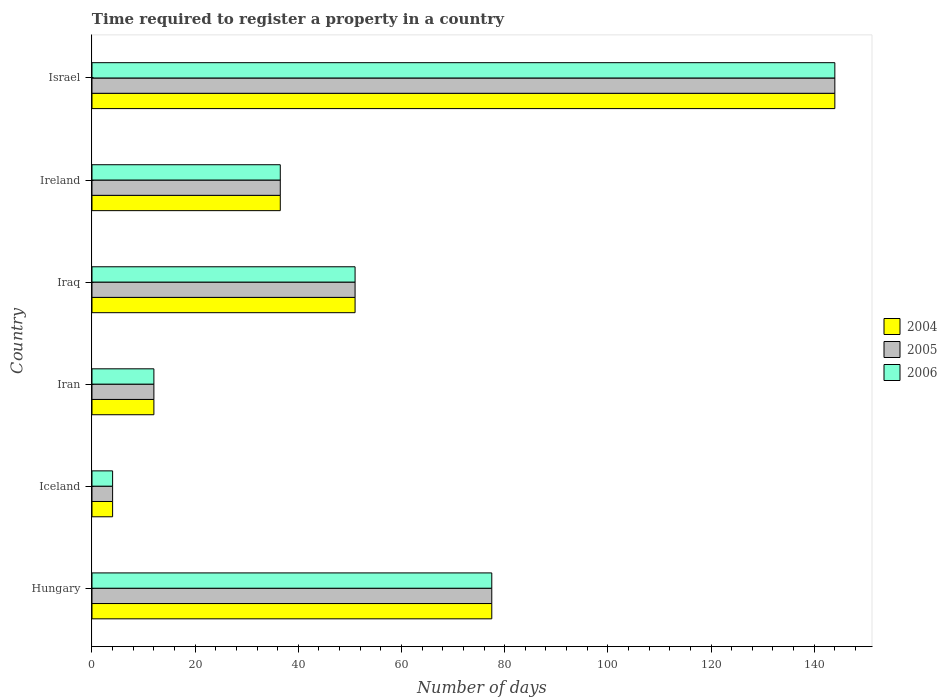How many groups of bars are there?
Your answer should be compact. 6. Are the number of bars on each tick of the Y-axis equal?
Provide a short and direct response. Yes. How many bars are there on the 1st tick from the top?
Keep it short and to the point. 3. What is the number of days required to register a property in 2004 in Iran?
Provide a short and direct response. 12. Across all countries, what is the maximum number of days required to register a property in 2006?
Your response must be concise. 144. Across all countries, what is the minimum number of days required to register a property in 2005?
Provide a succinct answer. 4. What is the total number of days required to register a property in 2006 in the graph?
Keep it short and to the point. 325. What is the difference between the number of days required to register a property in 2005 in Iraq and the number of days required to register a property in 2006 in Iran?
Give a very brief answer. 39. What is the average number of days required to register a property in 2005 per country?
Offer a very short reply. 54.17. In how many countries, is the number of days required to register a property in 2006 greater than 100 days?
Your answer should be compact. 1. What is the ratio of the number of days required to register a property in 2004 in Hungary to that in Iraq?
Ensure brevity in your answer.  1.52. Is the number of days required to register a property in 2005 in Iceland less than that in Iraq?
Offer a terse response. Yes. What is the difference between the highest and the second highest number of days required to register a property in 2004?
Provide a succinct answer. 66.5. What is the difference between the highest and the lowest number of days required to register a property in 2004?
Ensure brevity in your answer.  140. What does the 3rd bar from the bottom in Iraq represents?
Your answer should be compact. 2006. Is it the case that in every country, the sum of the number of days required to register a property in 2006 and number of days required to register a property in 2005 is greater than the number of days required to register a property in 2004?
Offer a terse response. Yes. How many bars are there?
Your answer should be very brief. 18. How many countries are there in the graph?
Offer a terse response. 6. Are the values on the major ticks of X-axis written in scientific E-notation?
Give a very brief answer. No. How many legend labels are there?
Your answer should be compact. 3. What is the title of the graph?
Keep it short and to the point. Time required to register a property in a country. Does "2012" appear as one of the legend labels in the graph?
Provide a short and direct response. No. What is the label or title of the X-axis?
Give a very brief answer. Number of days. What is the label or title of the Y-axis?
Your answer should be compact. Country. What is the Number of days in 2004 in Hungary?
Give a very brief answer. 77.5. What is the Number of days of 2005 in Hungary?
Your answer should be compact. 77.5. What is the Number of days in 2006 in Hungary?
Your answer should be very brief. 77.5. What is the Number of days in 2005 in Iceland?
Keep it short and to the point. 4. What is the Number of days in 2006 in Iceland?
Provide a short and direct response. 4. What is the Number of days in 2005 in Iran?
Give a very brief answer. 12. What is the Number of days in 2006 in Iran?
Offer a very short reply. 12. What is the Number of days in 2005 in Iraq?
Your answer should be compact. 51. What is the Number of days in 2006 in Iraq?
Provide a succinct answer. 51. What is the Number of days in 2004 in Ireland?
Your answer should be very brief. 36.5. What is the Number of days of 2005 in Ireland?
Your answer should be very brief. 36.5. What is the Number of days in 2006 in Ireland?
Offer a terse response. 36.5. What is the Number of days in 2004 in Israel?
Make the answer very short. 144. What is the Number of days in 2005 in Israel?
Keep it short and to the point. 144. What is the Number of days in 2006 in Israel?
Keep it short and to the point. 144. Across all countries, what is the maximum Number of days in 2004?
Your answer should be compact. 144. Across all countries, what is the maximum Number of days in 2005?
Offer a very short reply. 144. Across all countries, what is the maximum Number of days of 2006?
Provide a succinct answer. 144. Across all countries, what is the minimum Number of days in 2004?
Provide a short and direct response. 4. What is the total Number of days in 2004 in the graph?
Keep it short and to the point. 325. What is the total Number of days of 2005 in the graph?
Keep it short and to the point. 325. What is the total Number of days of 2006 in the graph?
Your answer should be very brief. 325. What is the difference between the Number of days in 2004 in Hungary and that in Iceland?
Ensure brevity in your answer.  73.5. What is the difference between the Number of days in 2005 in Hungary and that in Iceland?
Your answer should be very brief. 73.5. What is the difference between the Number of days of 2006 in Hungary and that in Iceland?
Give a very brief answer. 73.5. What is the difference between the Number of days of 2004 in Hungary and that in Iran?
Keep it short and to the point. 65.5. What is the difference between the Number of days in 2005 in Hungary and that in Iran?
Keep it short and to the point. 65.5. What is the difference between the Number of days of 2006 in Hungary and that in Iran?
Your answer should be compact. 65.5. What is the difference between the Number of days in 2004 in Hungary and that in Iraq?
Offer a terse response. 26.5. What is the difference between the Number of days of 2004 in Hungary and that in Ireland?
Provide a succinct answer. 41. What is the difference between the Number of days of 2005 in Hungary and that in Ireland?
Provide a succinct answer. 41. What is the difference between the Number of days of 2004 in Hungary and that in Israel?
Your answer should be very brief. -66.5. What is the difference between the Number of days in 2005 in Hungary and that in Israel?
Give a very brief answer. -66.5. What is the difference between the Number of days in 2006 in Hungary and that in Israel?
Your answer should be very brief. -66.5. What is the difference between the Number of days of 2004 in Iceland and that in Iran?
Your answer should be very brief. -8. What is the difference between the Number of days of 2005 in Iceland and that in Iran?
Your response must be concise. -8. What is the difference between the Number of days of 2004 in Iceland and that in Iraq?
Provide a short and direct response. -47. What is the difference between the Number of days of 2005 in Iceland and that in Iraq?
Your response must be concise. -47. What is the difference between the Number of days in 2006 in Iceland and that in Iraq?
Your answer should be compact. -47. What is the difference between the Number of days of 2004 in Iceland and that in Ireland?
Give a very brief answer. -32.5. What is the difference between the Number of days in 2005 in Iceland and that in Ireland?
Provide a succinct answer. -32.5. What is the difference between the Number of days of 2006 in Iceland and that in Ireland?
Keep it short and to the point. -32.5. What is the difference between the Number of days in 2004 in Iceland and that in Israel?
Keep it short and to the point. -140. What is the difference between the Number of days of 2005 in Iceland and that in Israel?
Ensure brevity in your answer.  -140. What is the difference between the Number of days in 2006 in Iceland and that in Israel?
Your response must be concise. -140. What is the difference between the Number of days in 2004 in Iran and that in Iraq?
Your answer should be very brief. -39. What is the difference between the Number of days of 2005 in Iran and that in Iraq?
Your answer should be compact. -39. What is the difference between the Number of days of 2006 in Iran and that in Iraq?
Ensure brevity in your answer.  -39. What is the difference between the Number of days of 2004 in Iran and that in Ireland?
Provide a succinct answer. -24.5. What is the difference between the Number of days in 2005 in Iran and that in Ireland?
Your response must be concise. -24.5. What is the difference between the Number of days in 2006 in Iran and that in Ireland?
Your response must be concise. -24.5. What is the difference between the Number of days in 2004 in Iran and that in Israel?
Provide a succinct answer. -132. What is the difference between the Number of days of 2005 in Iran and that in Israel?
Provide a succinct answer. -132. What is the difference between the Number of days in 2006 in Iran and that in Israel?
Provide a succinct answer. -132. What is the difference between the Number of days in 2004 in Iraq and that in Ireland?
Ensure brevity in your answer.  14.5. What is the difference between the Number of days in 2005 in Iraq and that in Ireland?
Keep it short and to the point. 14.5. What is the difference between the Number of days in 2004 in Iraq and that in Israel?
Your response must be concise. -93. What is the difference between the Number of days of 2005 in Iraq and that in Israel?
Provide a short and direct response. -93. What is the difference between the Number of days of 2006 in Iraq and that in Israel?
Keep it short and to the point. -93. What is the difference between the Number of days in 2004 in Ireland and that in Israel?
Your response must be concise. -107.5. What is the difference between the Number of days in 2005 in Ireland and that in Israel?
Keep it short and to the point. -107.5. What is the difference between the Number of days of 2006 in Ireland and that in Israel?
Your answer should be very brief. -107.5. What is the difference between the Number of days of 2004 in Hungary and the Number of days of 2005 in Iceland?
Your answer should be very brief. 73.5. What is the difference between the Number of days of 2004 in Hungary and the Number of days of 2006 in Iceland?
Keep it short and to the point. 73.5. What is the difference between the Number of days of 2005 in Hungary and the Number of days of 2006 in Iceland?
Your answer should be very brief. 73.5. What is the difference between the Number of days of 2004 in Hungary and the Number of days of 2005 in Iran?
Your answer should be compact. 65.5. What is the difference between the Number of days in 2004 in Hungary and the Number of days in 2006 in Iran?
Offer a terse response. 65.5. What is the difference between the Number of days in 2005 in Hungary and the Number of days in 2006 in Iran?
Offer a very short reply. 65.5. What is the difference between the Number of days of 2004 in Hungary and the Number of days of 2005 in Iraq?
Provide a short and direct response. 26.5. What is the difference between the Number of days in 2004 in Hungary and the Number of days in 2006 in Iraq?
Make the answer very short. 26.5. What is the difference between the Number of days of 2005 in Hungary and the Number of days of 2006 in Iraq?
Provide a short and direct response. 26.5. What is the difference between the Number of days in 2004 in Hungary and the Number of days in 2005 in Ireland?
Your response must be concise. 41. What is the difference between the Number of days in 2004 in Hungary and the Number of days in 2005 in Israel?
Your answer should be very brief. -66.5. What is the difference between the Number of days in 2004 in Hungary and the Number of days in 2006 in Israel?
Make the answer very short. -66.5. What is the difference between the Number of days of 2005 in Hungary and the Number of days of 2006 in Israel?
Make the answer very short. -66.5. What is the difference between the Number of days of 2004 in Iceland and the Number of days of 2005 in Iran?
Keep it short and to the point. -8. What is the difference between the Number of days in 2004 in Iceland and the Number of days in 2006 in Iran?
Provide a succinct answer. -8. What is the difference between the Number of days in 2004 in Iceland and the Number of days in 2005 in Iraq?
Your answer should be compact. -47. What is the difference between the Number of days in 2004 in Iceland and the Number of days in 2006 in Iraq?
Give a very brief answer. -47. What is the difference between the Number of days in 2005 in Iceland and the Number of days in 2006 in Iraq?
Give a very brief answer. -47. What is the difference between the Number of days of 2004 in Iceland and the Number of days of 2005 in Ireland?
Your answer should be compact. -32.5. What is the difference between the Number of days of 2004 in Iceland and the Number of days of 2006 in Ireland?
Provide a succinct answer. -32.5. What is the difference between the Number of days of 2005 in Iceland and the Number of days of 2006 in Ireland?
Your answer should be very brief. -32.5. What is the difference between the Number of days in 2004 in Iceland and the Number of days in 2005 in Israel?
Give a very brief answer. -140. What is the difference between the Number of days in 2004 in Iceland and the Number of days in 2006 in Israel?
Your response must be concise. -140. What is the difference between the Number of days of 2005 in Iceland and the Number of days of 2006 in Israel?
Make the answer very short. -140. What is the difference between the Number of days of 2004 in Iran and the Number of days of 2005 in Iraq?
Provide a succinct answer. -39. What is the difference between the Number of days in 2004 in Iran and the Number of days in 2006 in Iraq?
Make the answer very short. -39. What is the difference between the Number of days in 2005 in Iran and the Number of days in 2006 in Iraq?
Your response must be concise. -39. What is the difference between the Number of days in 2004 in Iran and the Number of days in 2005 in Ireland?
Offer a terse response. -24.5. What is the difference between the Number of days of 2004 in Iran and the Number of days of 2006 in Ireland?
Your answer should be very brief. -24.5. What is the difference between the Number of days of 2005 in Iran and the Number of days of 2006 in Ireland?
Offer a very short reply. -24.5. What is the difference between the Number of days of 2004 in Iran and the Number of days of 2005 in Israel?
Your answer should be very brief. -132. What is the difference between the Number of days in 2004 in Iran and the Number of days in 2006 in Israel?
Provide a short and direct response. -132. What is the difference between the Number of days in 2005 in Iran and the Number of days in 2006 in Israel?
Your response must be concise. -132. What is the difference between the Number of days in 2004 in Iraq and the Number of days in 2005 in Israel?
Make the answer very short. -93. What is the difference between the Number of days of 2004 in Iraq and the Number of days of 2006 in Israel?
Ensure brevity in your answer.  -93. What is the difference between the Number of days of 2005 in Iraq and the Number of days of 2006 in Israel?
Keep it short and to the point. -93. What is the difference between the Number of days in 2004 in Ireland and the Number of days in 2005 in Israel?
Your answer should be compact. -107.5. What is the difference between the Number of days of 2004 in Ireland and the Number of days of 2006 in Israel?
Provide a succinct answer. -107.5. What is the difference between the Number of days of 2005 in Ireland and the Number of days of 2006 in Israel?
Give a very brief answer. -107.5. What is the average Number of days in 2004 per country?
Offer a very short reply. 54.17. What is the average Number of days of 2005 per country?
Your answer should be compact. 54.17. What is the average Number of days in 2006 per country?
Your response must be concise. 54.17. What is the difference between the Number of days of 2005 and Number of days of 2006 in Hungary?
Provide a succinct answer. 0. What is the difference between the Number of days in 2004 and Number of days in 2006 in Iceland?
Provide a succinct answer. 0. What is the difference between the Number of days in 2005 and Number of days in 2006 in Iceland?
Your answer should be very brief. 0. What is the difference between the Number of days in 2004 and Number of days in 2005 in Iran?
Offer a terse response. 0. What is the difference between the Number of days of 2004 and Number of days of 2006 in Iran?
Offer a terse response. 0. What is the difference between the Number of days of 2005 and Number of days of 2006 in Iran?
Give a very brief answer. 0. What is the difference between the Number of days in 2004 and Number of days in 2005 in Iraq?
Offer a very short reply. 0. What is the difference between the Number of days of 2004 and Number of days of 2006 in Iraq?
Ensure brevity in your answer.  0. What is the difference between the Number of days of 2005 and Number of days of 2006 in Iraq?
Your response must be concise. 0. What is the difference between the Number of days in 2004 and Number of days in 2006 in Ireland?
Offer a terse response. 0. What is the difference between the Number of days in 2005 and Number of days in 2006 in Ireland?
Make the answer very short. 0. What is the ratio of the Number of days in 2004 in Hungary to that in Iceland?
Offer a very short reply. 19.38. What is the ratio of the Number of days of 2005 in Hungary to that in Iceland?
Offer a terse response. 19.38. What is the ratio of the Number of days of 2006 in Hungary to that in Iceland?
Give a very brief answer. 19.38. What is the ratio of the Number of days of 2004 in Hungary to that in Iran?
Your answer should be very brief. 6.46. What is the ratio of the Number of days of 2005 in Hungary to that in Iran?
Provide a succinct answer. 6.46. What is the ratio of the Number of days of 2006 in Hungary to that in Iran?
Give a very brief answer. 6.46. What is the ratio of the Number of days in 2004 in Hungary to that in Iraq?
Give a very brief answer. 1.52. What is the ratio of the Number of days of 2005 in Hungary to that in Iraq?
Offer a very short reply. 1.52. What is the ratio of the Number of days of 2006 in Hungary to that in Iraq?
Your answer should be very brief. 1.52. What is the ratio of the Number of days in 2004 in Hungary to that in Ireland?
Provide a succinct answer. 2.12. What is the ratio of the Number of days of 2005 in Hungary to that in Ireland?
Offer a very short reply. 2.12. What is the ratio of the Number of days in 2006 in Hungary to that in Ireland?
Your answer should be compact. 2.12. What is the ratio of the Number of days of 2004 in Hungary to that in Israel?
Keep it short and to the point. 0.54. What is the ratio of the Number of days of 2005 in Hungary to that in Israel?
Ensure brevity in your answer.  0.54. What is the ratio of the Number of days in 2006 in Hungary to that in Israel?
Offer a terse response. 0.54. What is the ratio of the Number of days in 2005 in Iceland to that in Iran?
Keep it short and to the point. 0.33. What is the ratio of the Number of days in 2006 in Iceland to that in Iran?
Your answer should be compact. 0.33. What is the ratio of the Number of days in 2004 in Iceland to that in Iraq?
Provide a short and direct response. 0.08. What is the ratio of the Number of days of 2005 in Iceland to that in Iraq?
Your response must be concise. 0.08. What is the ratio of the Number of days of 2006 in Iceland to that in Iraq?
Ensure brevity in your answer.  0.08. What is the ratio of the Number of days in 2004 in Iceland to that in Ireland?
Provide a succinct answer. 0.11. What is the ratio of the Number of days in 2005 in Iceland to that in Ireland?
Your answer should be very brief. 0.11. What is the ratio of the Number of days of 2006 in Iceland to that in Ireland?
Provide a short and direct response. 0.11. What is the ratio of the Number of days of 2004 in Iceland to that in Israel?
Offer a very short reply. 0.03. What is the ratio of the Number of days in 2005 in Iceland to that in Israel?
Your answer should be very brief. 0.03. What is the ratio of the Number of days in 2006 in Iceland to that in Israel?
Ensure brevity in your answer.  0.03. What is the ratio of the Number of days in 2004 in Iran to that in Iraq?
Your response must be concise. 0.24. What is the ratio of the Number of days in 2005 in Iran to that in Iraq?
Offer a very short reply. 0.24. What is the ratio of the Number of days of 2006 in Iran to that in Iraq?
Offer a terse response. 0.24. What is the ratio of the Number of days of 2004 in Iran to that in Ireland?
Ensure brevity in your answer.  0.33. What is the ratio of the Number of days in 2005 in Iran to that in Ireland?
Provide a succinct answer. 0.33. What is the ratio of the Number of days in 2006 in Iran to that in Ireland?
Ensure brevity in your answer.  0.33. What is the ratio of the Number of days of 2004 in Iran to that in Israel?
Keep it short and to the point. 0.08. What is the ratio of the Number of days of 2005 in Iran to that in Israel?
Offer a terse response. 0.08. What is the ratio of the Number of days in 2006 in Iran to that in Israel?
Provide a succinct answer. 0.08. What is the ratio of the Number of days of 2004 in Iraq to that in Ireland?
Provide a succinct answer. 1.4. What is the ratio of the Number of days in 2005 in Iraq to that in Ireland?
Offer a very short reply. 1.4. What is the ratio of the Number of days of 2006 in Iraq to that in Ireland?
Offer a very short reply. 1.4. What is the ratio of the Number of days in 2004 in Iraq to that in Israel?
Make the answer very short. 0.35. What is the ratio of the Number of days in 2005 in Iraq to that in Israel?
Ensure brevity in your answer.  0.35. What is the ratio of the Number of days of 2006 in Iraq to that in Israel?
Provide a succinct answer. 0.35. What is the ratio of the Number of days of 2004 in Ireland to that in Israel?
Make the answer very short. 0.25. What is the ratio of the Number of days in 2005 in Ireland to that in Israel?
Ensure brevity in your answer.  0.25. What is the ratio of the Number of days of 2006 in Ireland to that in Israel?
Provide a short and direct response. 0.25. What is the difference between the highest and the second highest Number of days in 2004?
Your response must be concise. 66.5. What is the difference between the highest and the second highest Number of days in 2005?
Offer a very short reply. 66.5. What is the difference between the highest and the second highest Number of days of 2006?
Your answer should be compact. 66.5. What is the difference between the highest and the lowest Number of days in 2004?
Your response must be concise. 140. What is the difference between the highest and the lowest Number of days in 2005?
Offer a terse response. 140. What is the difference between the highest and the lowest Number of days of 2006?
Offer a very short reply. 140. 